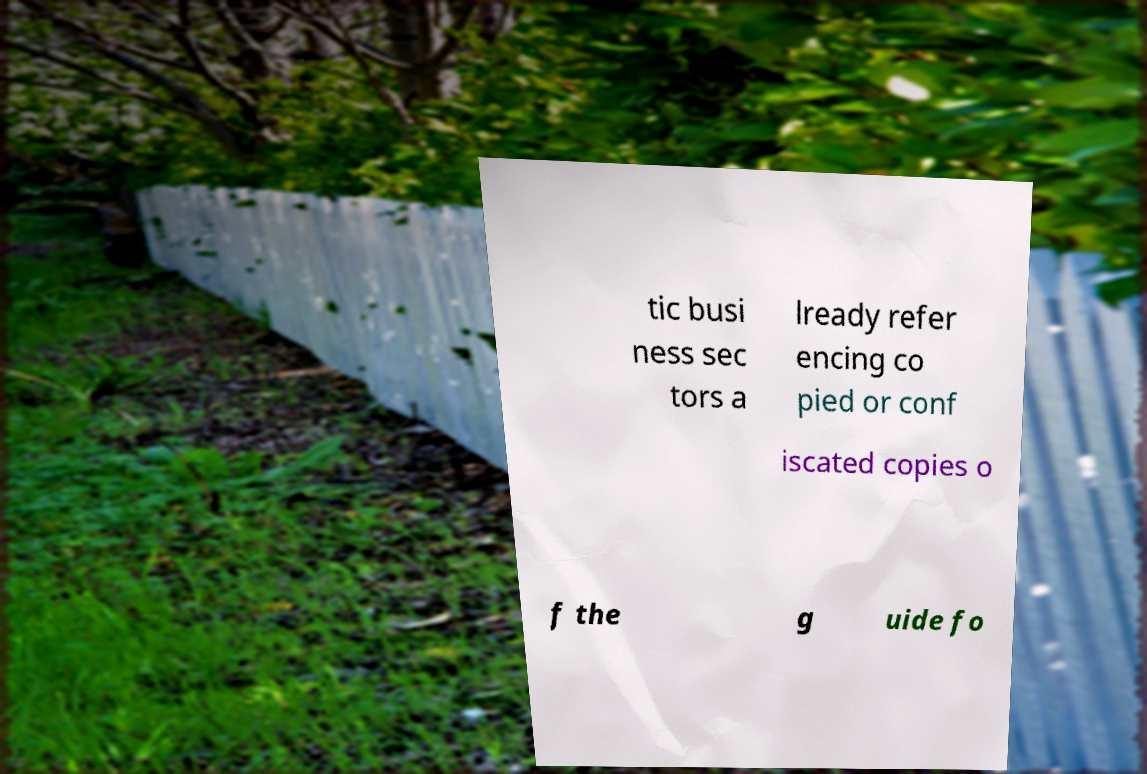Please read and relay the text visible in this image. What does it say? tic busi ness sec tors a lready refer encing co pied or conf iscated copies o f the g uide fo 